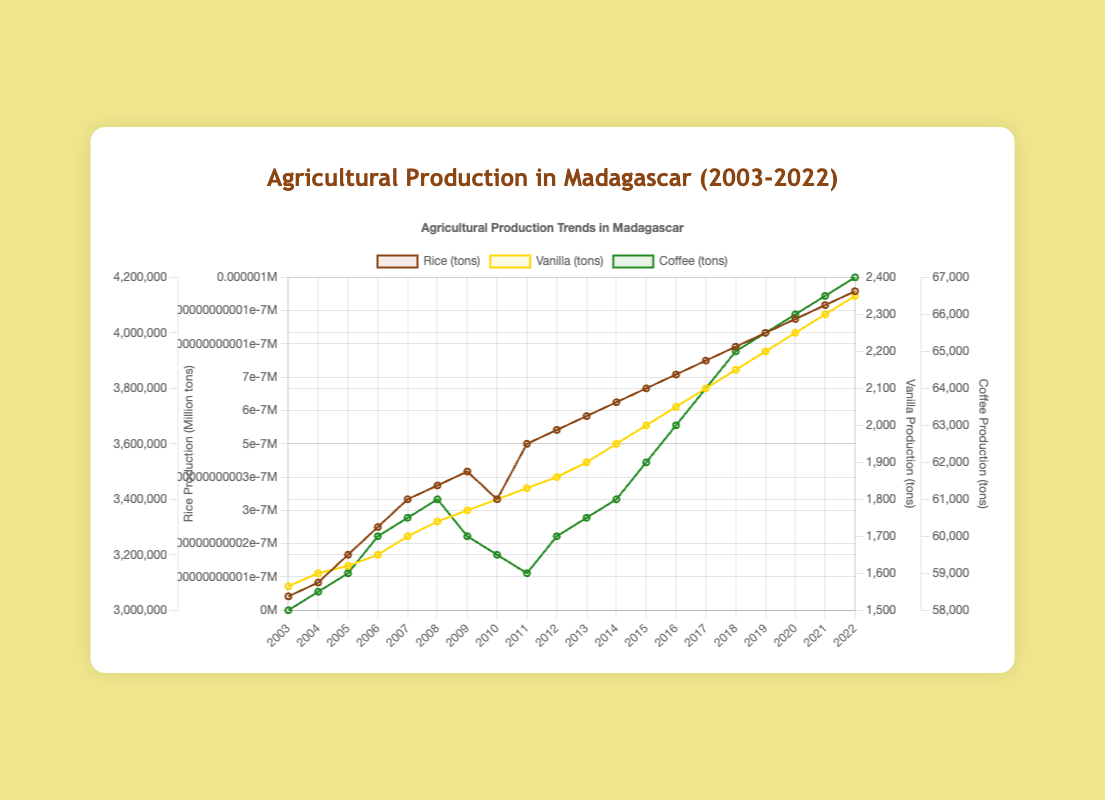What is the trend of rice production in Madagascar over the past 20 years? First, observe the line representing rice production. It starts at 3,050,000 tons in 2003 and gradually increases, reaching 4,150,000 tons in 2022. This indicates a rising trend over the 20-year period.
Answer: Increasing How did vanilla production change between 2010 and 2015? Look at the data points for vanilla production in 2010 and 2015. It increased from 1,800 tons in 2010 to 2,000 tons in 2015.
Answer: Increased by 200 tons Which year had the highest coffee production, and what was the amount? Locate the peak of the coffee production line. In 2022, coffee production reached its highest at 67,000 tons.
Answer: 2022, 67,000 tons When was the rice production the lowest, and what was the amount? Identify the lowest point of the rice production line. It was lowest in 2003, at 3,050,000 tons.
Answer: 2003, 3,050,000 tons Compare the trends of vanilla and coffee production from 2003 to 2022. Vanilla production consistently increased from 1,565 tons to 2,350 tons. Coffee production fluctuated but generally increased from 58,000 tons to 67,000 tons. Both show an overall upward trend, although vanilla's increase is steadier.
Answer: Both increasing; vanilla steadily, coffee with fluctuations What was the average rice production from 2015 to 2020? Calculate the average by summing the rice production values from 2015 to 2020 and dividing by the number of years: (3,800,000 + 3,850,000 + 3,900,000 + 3,950,000 + 4,000,000 + 4,050,000) / 6.
Answer: 3,925,000 tons By how much did rice production increase from 2003 to 2022? Subtract the amount of rice produced in 2003 from the amount produced in 2022: 4,150,000 - 3,050,000.
Answer: 1,100,000 tons Between which consecutive years did coffee production see the highest increase? Compare year-to-year changes in coffee production to identify the highest increase. The largest increase was from 2013 to 2014, going from 60,500 to 61,000, a rise of 1,500 tons.
Answer: 2013-2014, 1,500 tons How does the increase in vanilla production compare to the increase in coffee production over 20 years? Calculate the total increase for both: Vanilla increased 2,350 - 1,565 = 785 tons. Coffee increased 67,000 - 58,000 = 9,000 tons. Coffee production increased more in total, but percentage-wise vanilla had a higher rate of increase.
Answer: Vanilla: 785 tons, Coffee: 9,000 tons What are the visual differences between the trends of rice, vanilla, and coffee production? Observe the color and pattern of each line: Rice has a brown line with a steady upward trend; Vanilla has a yellow line with a smooth, continuous rise; Coffee has a green line showing minor fluctuations but generally rises.
Answer: Rice: brown, steady upward; Vanilla: yellow, continuous rise; Coffee: green, minor fluctuations 